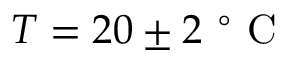<formula> <loc_0><loc_0><loc_500><loc_500>{ T = 2 0 \pm 2 ^ { \circ } C }</formula> 